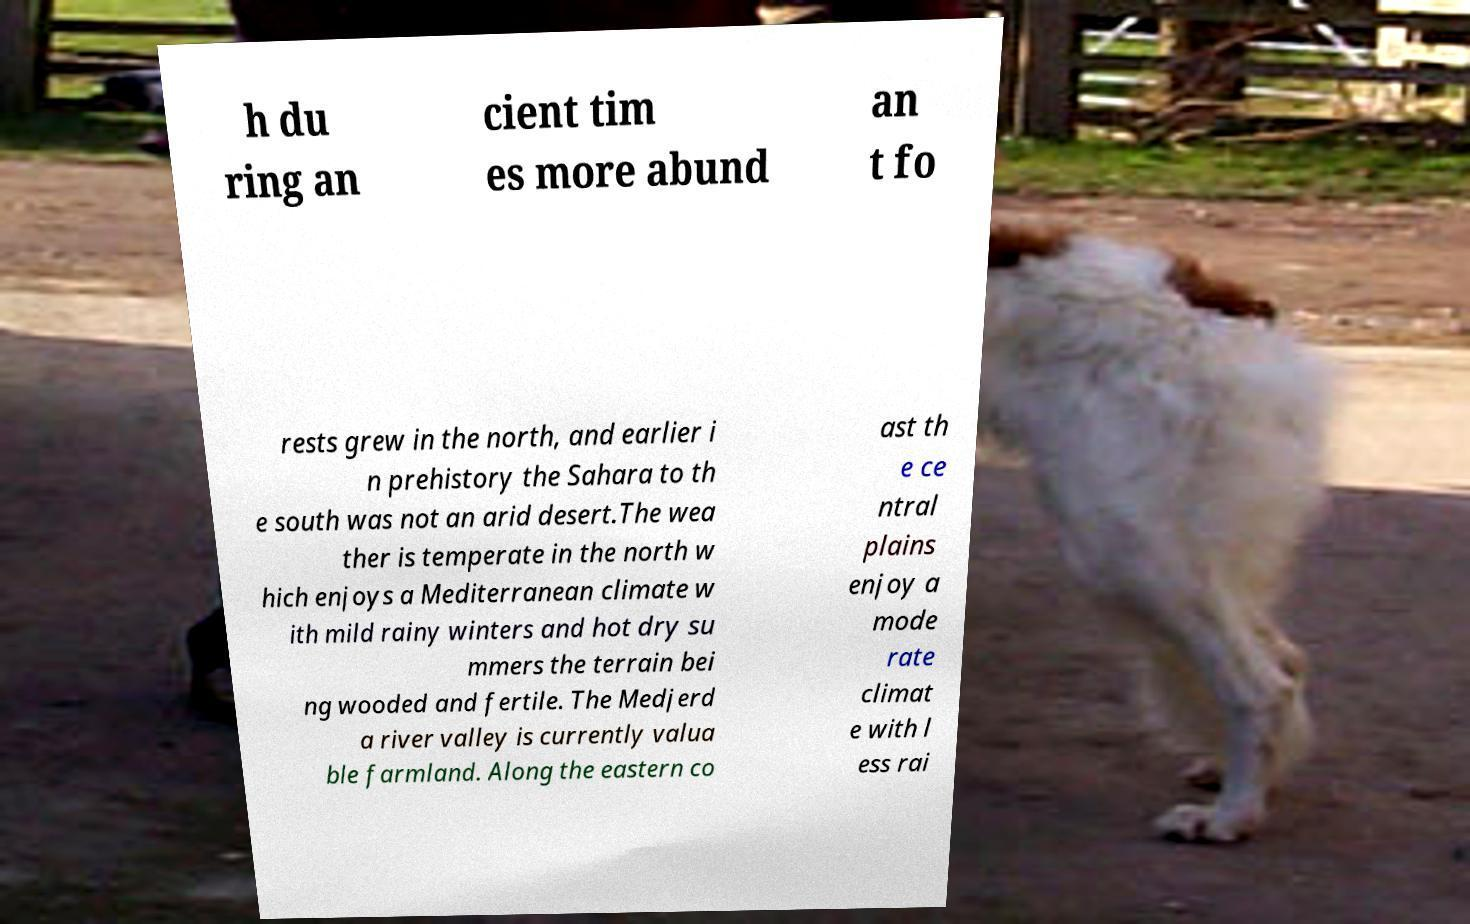There's text embedded in this image that I need extracted. Can you transcribe it verbatim? h du ring an cient tim es more abund an t fo rests grew in the north, and earlier i n prehistory the Sahara to th e south was not an arid desert.The wea ther is temperate in the north w hich enjoys a Mediterranean climate w ith mild rainy winters and hot dry su mmers the terrain bei ng wooded and fertile. The Medjerd a river valley is currently valua ble farmland. Along the eastern co ast th e ce ntral plains enjoy a mode rate climat e with l ess rai 